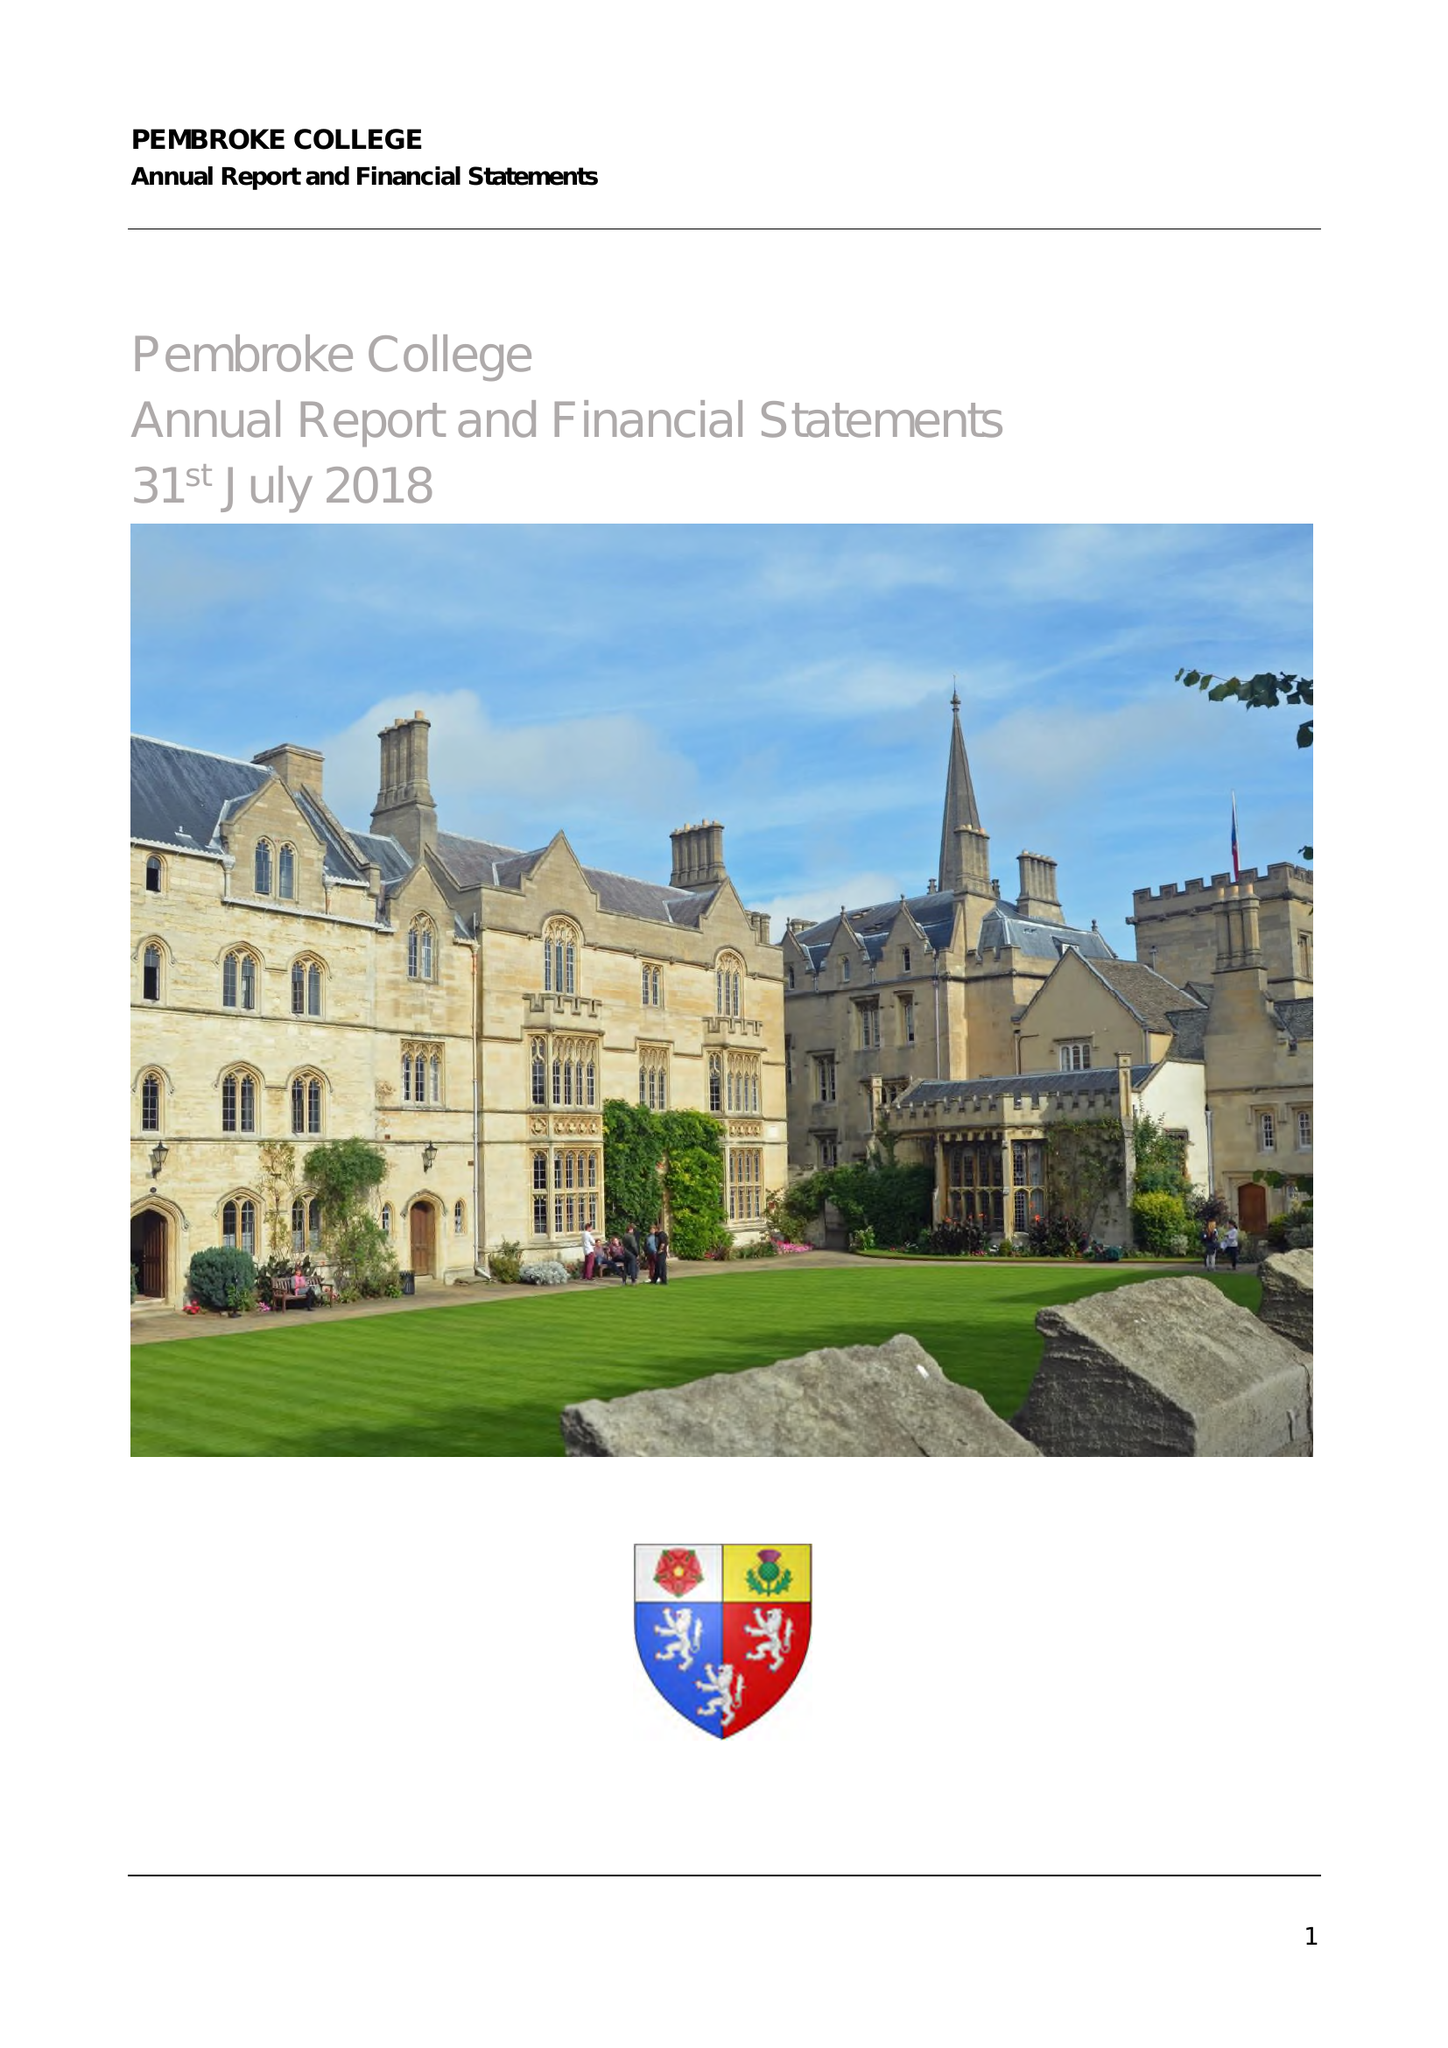What is the value for the address__post_town?
Answer the question using a single word or phrase. OXFORD 